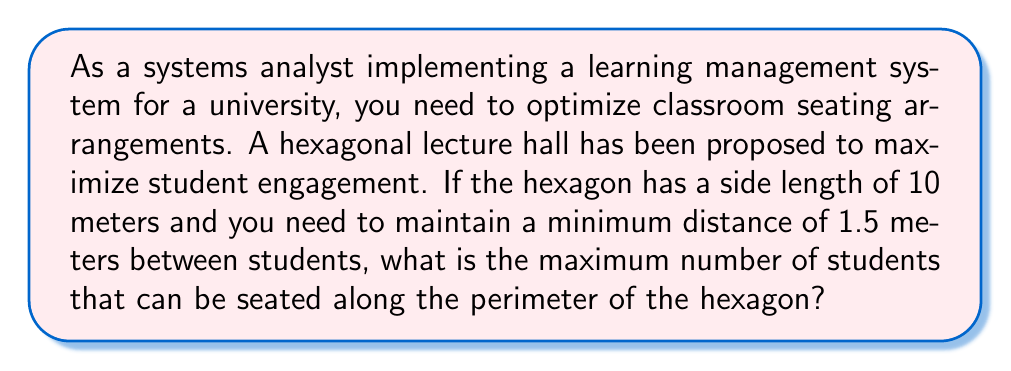Show me your answer to this math problem. Let's approach this step-by-step:

1) First, we need to calculate the perimeter of the hexagon:
   $$\text{Perimeter} = 6 \times \text{side length} = 6 \times 10 = 60 \text{ meters}$$

2) Now, we need to determine how much space each student occupies:
   - Each student needs 1.5 meters of space
   - We can represent this as: 1 student per 1.5 meters

3) To find the maximum number of students, we divide the perimeter by the space each student occupies:
   $$\text{Max students} = \frac{\text{Perimeter}}{\text{Space per student}} = \frac{60}{1.5} = 40$$

4) However, since we can't have a fractional number of students, we need to round down to the nearest whole number.

5) We can verify this result by calculating the space occupied:
   $$40 \text{ students} \times 1.5 \text{ meters} = 60 \text{ meters}$$
   This exactly matches the perimeter, confirming our calculation.

[asy]
unitsize(10mm);
pair A = (0,0), B = (1,0), C = (1.5, 0.866), D = (1, 1.732), E = (0, 1.732), F = (-0.5, 0.866);
draw(A--B--C--D--E--F--cycle);
label("10m", (A+B)/2, S);
dot(A); dot(B); dot(C); dot(D); dot(E); dot(F);
[/asy]
Answer: 40 students 